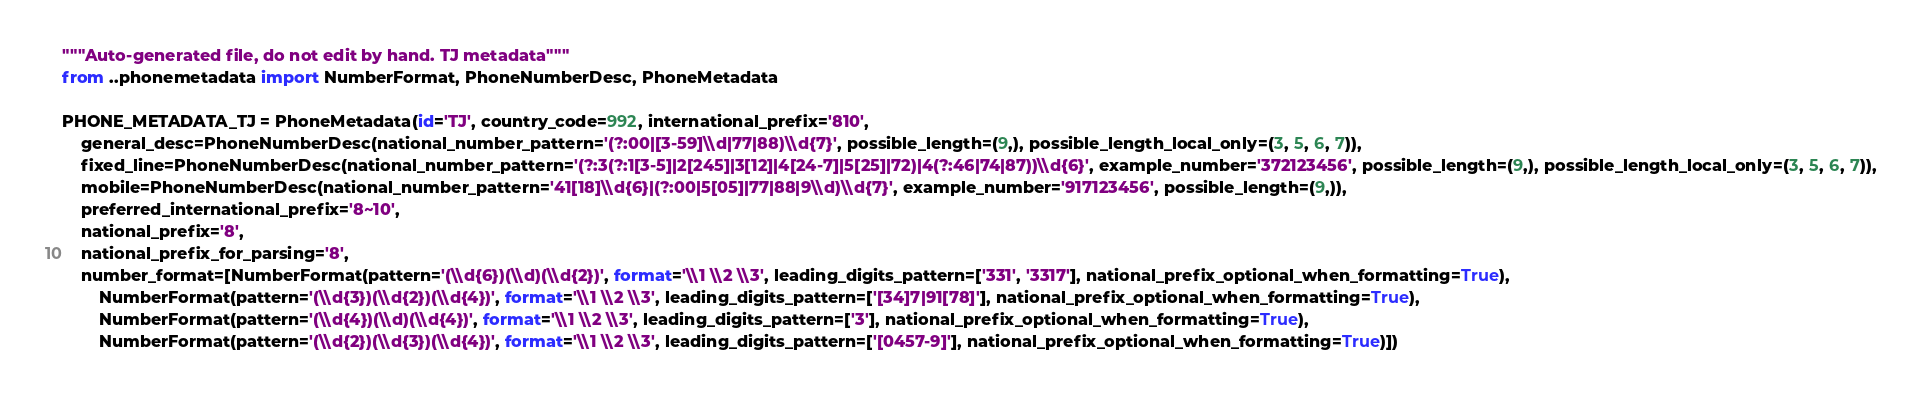<code> <loc_0><loc_0><loc_500><loc_500><_Python_>"""Auto-generated file, do not edit by hand. TJ metadata"""
from ..phonemetadata import NumberFormat, PhoneNumberDesc, PhoneMetadata

PHONE_METADATA_TJ = PhoneMetadata(id='TJ', country_code=992, international_prefix='810',
    general_desc=PhoneNumberDesc(national_number_pattern='(?:00|[3-59]\\d|77|88)\\d{7}', possible_length=(9,), possible_length_local_only=(3, 5, 6, 7)),
    fixed_line=PhoneNumberDesc(national_number_pattern='(?:3(?:1[3-5]|2[245]|3[12]|4[24-7]|5[25]|72)|4(?:46|74|87))\\d{6}', example_number='372123456', possible_length=(9,), possible_length_local_only=(3, 5, 6, 7)),
    mobile=PhoneNumberDesc(national_number_pattern='41[18]\\d{6}|(?:00|5[05]|77|88|9\\d)\\d{7}', example_number='917123456', possible_length=(9,)),
    preferred_international_prefix='8~10',
    national_prefix='8',
    national_prefix_for_parsing='8',
    number_format=[NumberFormat(pattern='(\\d{6})(\\d)(\\d{2})', format='\\1 \\2 \\3', leading_digits_pattern=['331', '3317'], national_prefix_optional_when_formatting=True),
        NumberFormat(pattern='(\\d{3})(\\d{2})(\\d{4})', format='\\1 \\2 \\3', leading_digits_pattern=['[34]7|91[78]'], national_prefix_optional_when_formatting=True),
        NumberFormat(pattern='(\\d{4})(\\d)(\\d{4})', format='\\1 \\2 \\3', leading_digits_pattern=['3'], national_prefix_optional_when_formatting=True),
        NumberFormat(pattern='(\\d{2})(\\d{3})(\\d{4})', format='\\1 \\2 \\3', leading_digits_pattern=['[0457-9]'], national_prefix_optional_when_formatting=True)])
</code> 